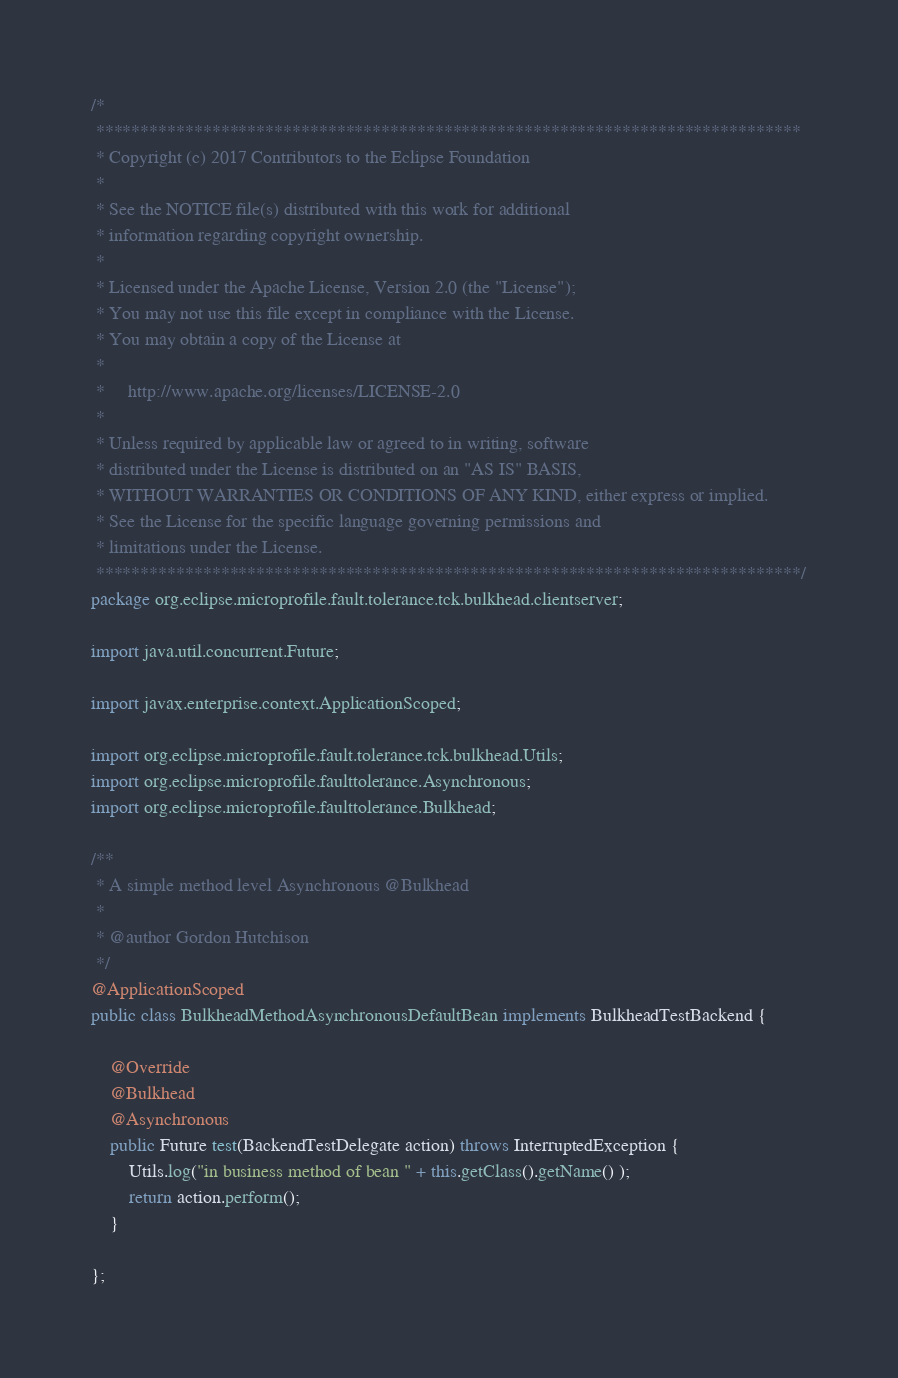Convert code to text. <code><loc_0><loc_0><loc_500><loc_500><_Java_>/*
 *******************************************************************************
 * Copyright (c) 2017 Contributors to the Eclipse Foundation
 *
 * See the NOTICE file(s) distributed with this work for additional
 * information regarding copyright ownership.
 *
 * Licensed under the Apache License, Version 2.0 (the "License");
 * You may not use this file except in compliance with the License.
 * You may obtain a copy of the License at
 *
 *     http://www.apache.org/licenses/LICENSE-2.0
 *
 * Unless required by applicable law or agreed to in writing, software
 * distributed under the License is distributed on an "AS IS" BASIS,
 * WITHOUT WARRANTIES OR CONDITIONS OF ANY KIND, either express or implied.
 * See the License for the specific language governing permissions and
 * limitations under the License.
 *******************************************************************************/
package org.eclipse.microprofile.fault.tolerance.tck.bulkhead.clientserver;

import java.util.concurrent.Future;

import javax.enterprise.context.ApplicationScoped;

import org.eclipse.microprofile.fault.tolerance.tck.bulkhead.Utils;
import org.eclipse.microprofile.faulttolerance.Asynchronous;
import org.eclipse.microprofile.faulttolerance.Bulkhead;

/**
 * A simple method level Asynchronous @Bulkhead 
 *
 * @author Gordon Hutchison
 */
@ApplicationScoped
public class BulkheadMethodAsynchronousDefaultBean implements BulkheadTestBackend {

    @Override
    @Bulkhead
    @Asynchronous
    public Future test(BackendTestDelegate action) throws InterruptedException {
        Utils.log("in business method of bean " + this.getClass().getName() );
        return action.perform();
    }

};</code> 